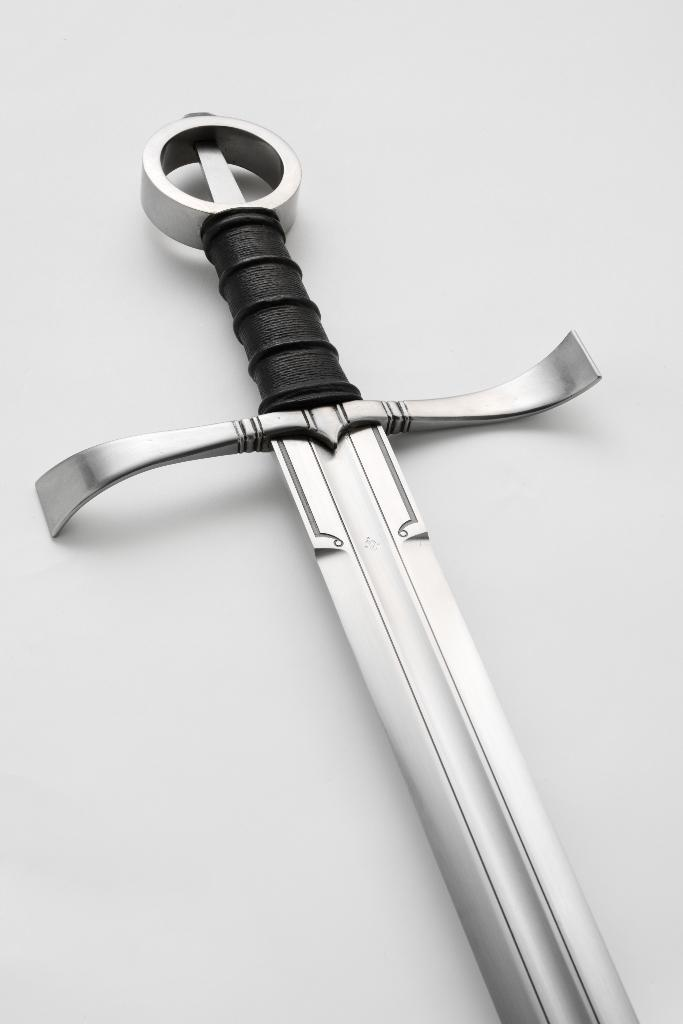What object can be seen in the image? There is a sword in the image. What degree of difficulty is the sword scene in the image? There is no scene in the image, as it only features a sword. Additionally, there is no indication of a degree of difficulty. 